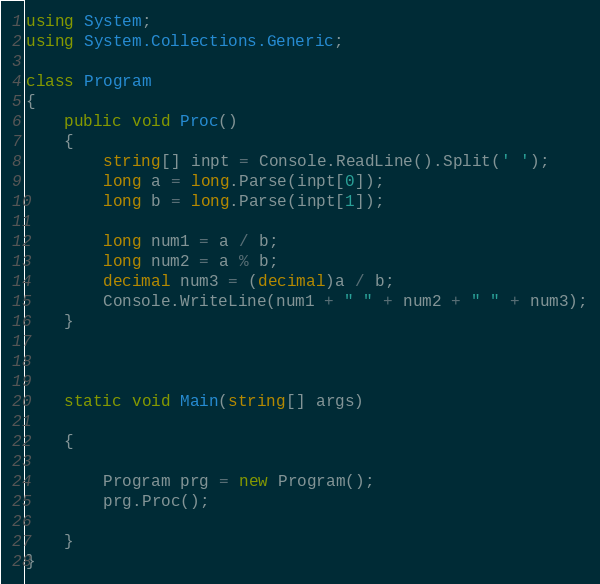Convert code to text. <code><loc_0><loc_0><loc_500><loc_500><_C#_>using System;
using System.Collections.Generic;

class Program
{
    public void Proc()
    {
        string[] inpt = Console.ReadLine().Split(' ');
        long a = long.Parse(inpt[0]);
        long b = long.Parse(inpt[1]);

        long num1 = a / b;
        long num2 = a % b;
        decimal num3 = (decimal)a / b;
        Console.WriteLine(num1 + " " + num2 + " " + num3);
    }



    static void Main(string[] args)

    {

        Program prg = new Program();
        prg.Proc();

    }
}</code> 